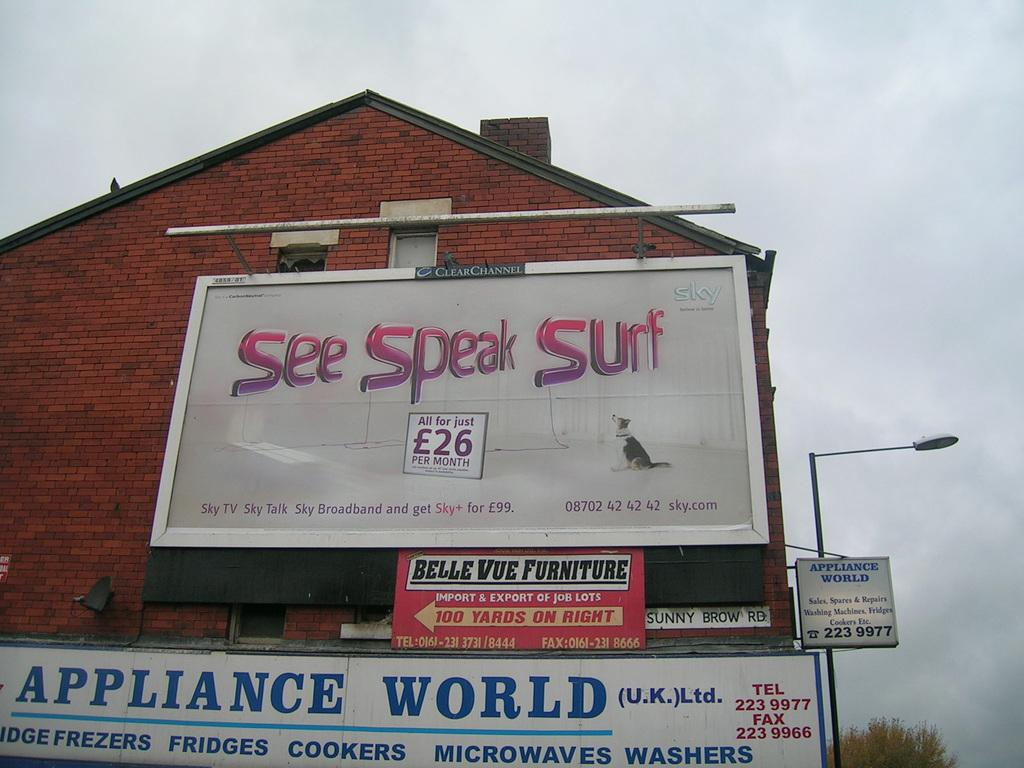<image>
Present a compact description of the photo's key features. A brick building has a billboard on it that says see speak surf. 